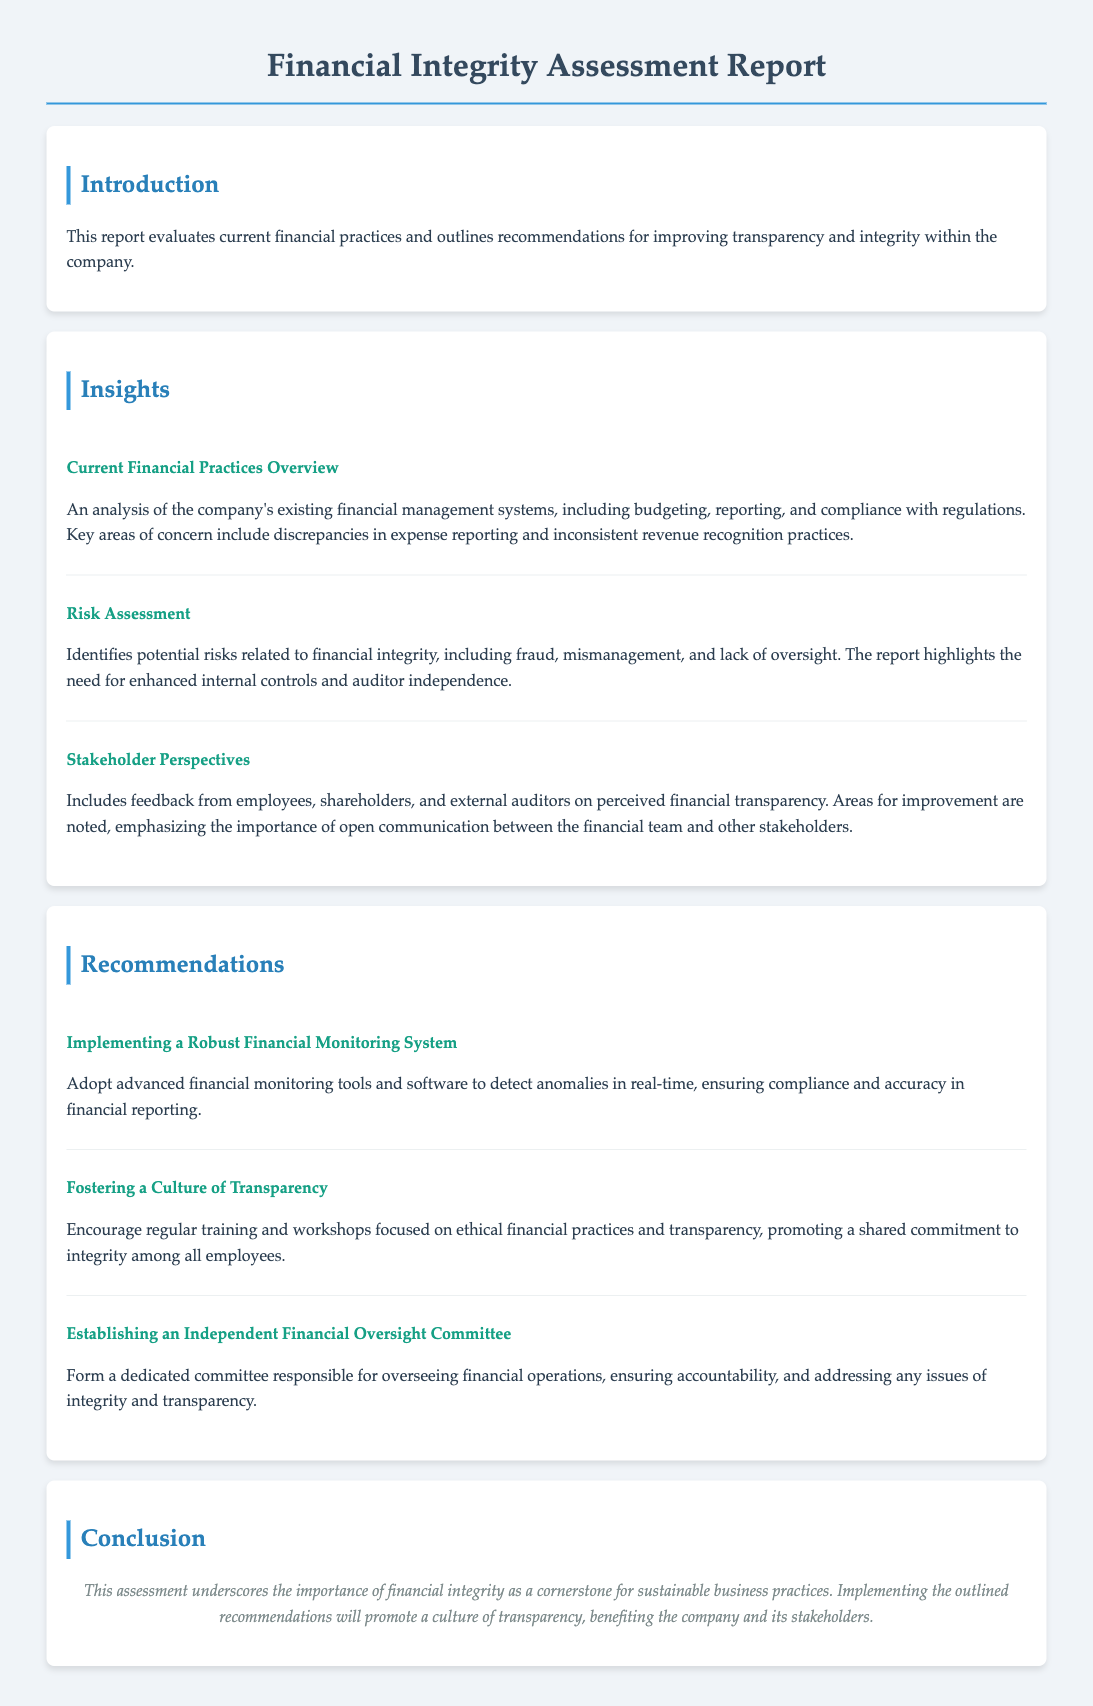What is the title of the report? The title provides the focus of the document, which is noted at the top.
Answer: Financial Integrity Assessment Report What is emphasized as key areas of concern in current financial practices? The section on current financial practices overview highlights specific issues regarding financial management.
Answer: Discrepancies in expense reporting and inconsistent revenue recognition practices What type of committee is recommended to be established? The recommendations section outlines specific actions to enhance financial integrity and oversight.
Answer: Independent Financial Oversight Committee What risk is highlighted as needing enhanced controls? Risks related to financial integrity are detailed in the risk assessment section.
Answer: Fraud How should the culture of transparency be fostered among employees? Recommendations include various methods to improve ethical practices and communication.
Answer: Regular training and workshops What does the conclusion indicate as a cornerstone for sustainable business practices? The conclusion summarizes the overarching theme regarding financial practices.
Answer: Financial integrity What role do stakeholder perspectives play in the assessment? Stakeholder feedback is an important aspect discussed in the insights section.
Answer: Perceived financial transparency Which financial monitoring system approach is suggested? The recommendations specify certain technological improvements to financial practices.
Answer: Robust Financial Monitoring System What is the primary focus of the introduction section? The introduction outlines the purpose of the assessment report.
Answer: Evaluates current financial practices and outlines recommendations 